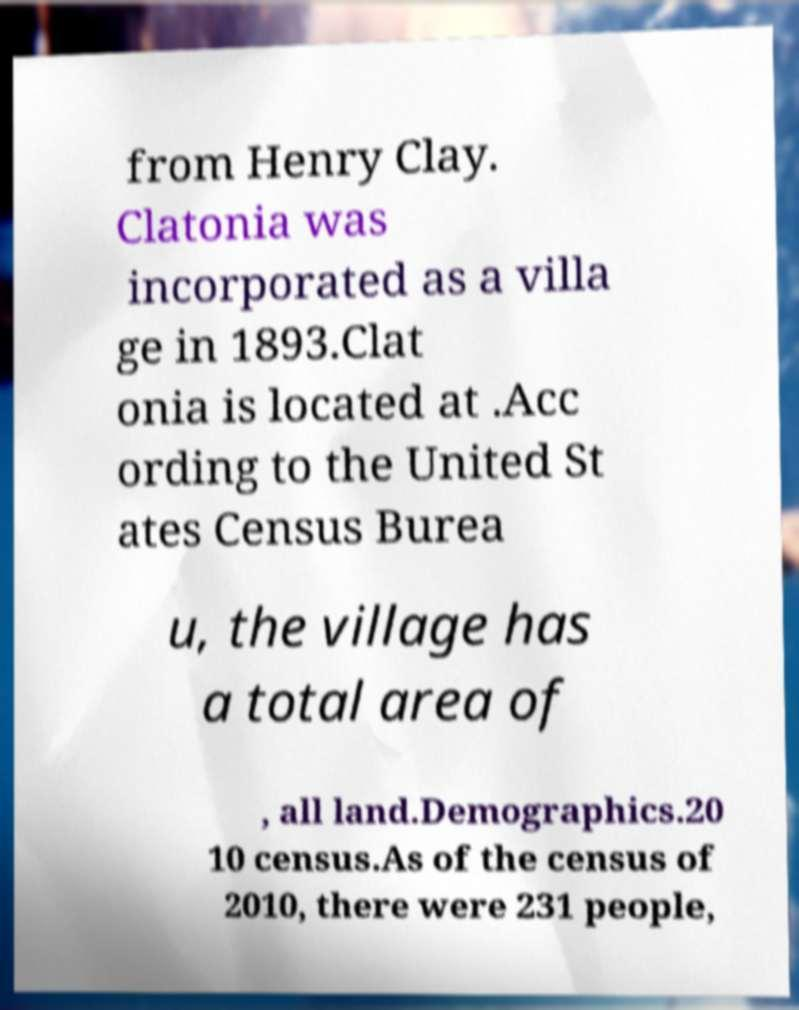Could you assist in decoding the text presented in this image and type it out clearly? from Henry Clay. Clatonia was incorporated as a villa ge in 1893.Clat onia is located at .Acc ording to the United St ates Census Burea u, the village has a total area of , all land.Demographics.20 10 census.As of the census of 2010, there were 231 people, 